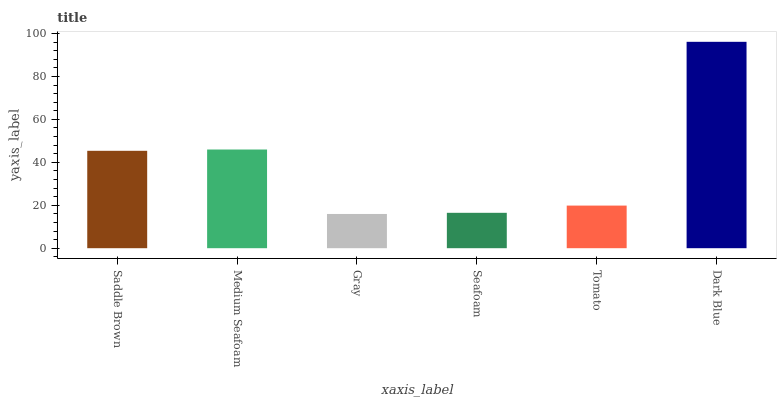Is Gray the minimum?
Answer yes or no. Yes. Is Dark Blue the maximum?
Answer yes or no. Yes. Is Medium Seafoam the minimum?
Answer yes or no. No. Is Medium Seafoam the maximum?
Answer yes or no. No. Is Medium Seafoam greater than Saddle Brown?
Answer yes or no. Yes. Is Saddle Brown less than Medium Seafoam?
Answer yes or no. Yes. Is Saddle Brown greater than Medium Seafoam?
Answer yes or no. No. Is Medium Seafoam less than Saddle Brown?
Answer yes or no. No. Is Saddle Brown the high median?
Answer yes or no. Yes. Is Tomato the low median?
Answer yes or no. Yes. Is Medium Seafoam the high median?
Answer yes or no. No. Is Medium Seafoam the low median?
Answer yes or no. No. 